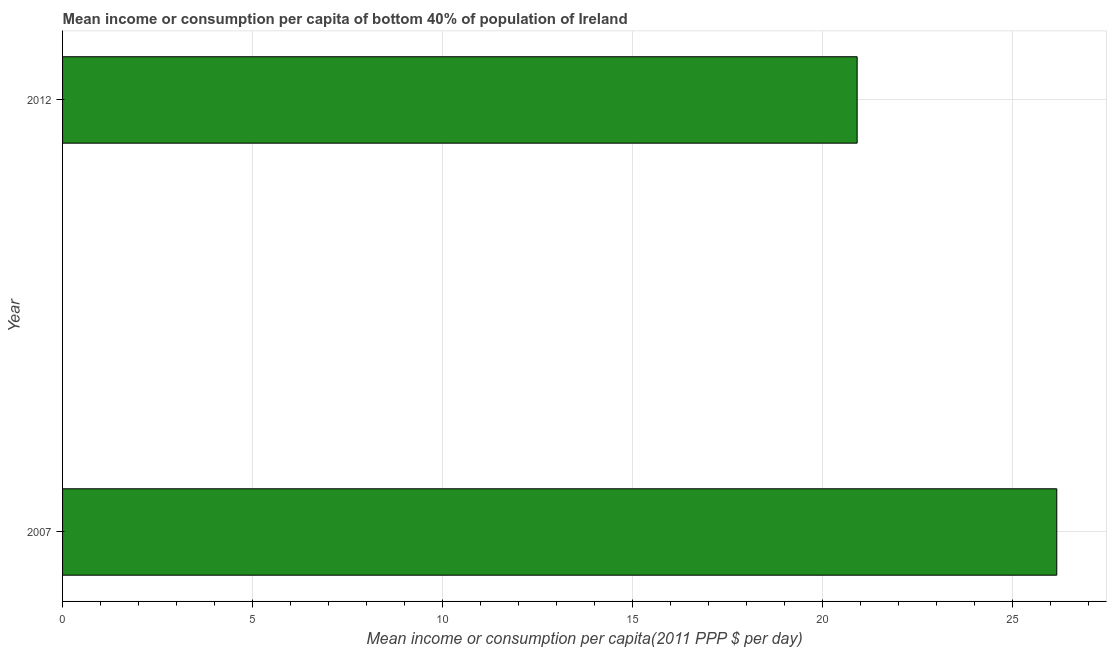What is the title of the graph?
Provide a short and direct response. Mean income or consumption per capita of bottom 40% of population of Ireland. What is the label or title of the X-axis?
Make the answer very short. Mean income or consumption per capita(2011 PPP $ per day). What is the label or title of the Y-axis?
Make the answer very short. Year. What is the mean income or consumption in 2012?
Ensure brevity in your answer.  20.92. Across all years, what is the maximum mean income or consumption?
Provide a short and direct response. 26.17. Across all years, what is the minimum mean income or consumption?
Ensure brevity in your answer.  20.92. In which year was the mean income or consumption maximum?
Keep it short and to the point. 2007. What is the sum of the mean income or consumption?
Your response must be concise. 47.09. What is the difference between the mean income or consumption in 2007 and 2012?
Your answer should be compact. 5.26. What is the average mean income or consumption per year?
Your response must be concise. 23.55. What is the median mean income or consumption?
Give a very brief answer. 23.55. In how many years, is the mean income or consumption greater than 10 $?
Give a very brief answer. 2. Do a majority of the years between 2007 and 2012 (inclusive) have mean income or consumption greater than 7 $?
Keep it short and to the point. Yes. What is the ratio of the mean income or consumption in 2007 to that in 2012?
Your response must be concise. 1.25. Is the mean income or consumption in 2007 less than that in 2012?
Ensure brevity in your answer.  No. In how many years, is the mean income or consumption greater than the average mean income or consumption taken over all years?
Provide a short and direct response. 1. Are all the bars in the graph horizontal?
Keep it short and to the point. Yes. How many years are there in the graph?
Provide a succinct answer. 2. What is the difference between two consecutive major ticks on the X-axis?
Offer a terse response. 5. What is the Mean income or consumption per capita(2011 PPP $ per day) in 2007?
Keep it short and to the point. 26.17. What is the Mean income or consumption per capita(2011 PPP $ per day) of 2012?
Provide a succinct answer. 20.92. What is the difference between the Mean income or consumption per capita(2011 PPP $ per day) in 2007 and 2012?
Your answer should be compact. 5.26. What is the ratio of the Mean income or consumption per capita(2011 PPP $ per day) in 2007 to that in 2012?
Your answer should be very brief. 1.25. 